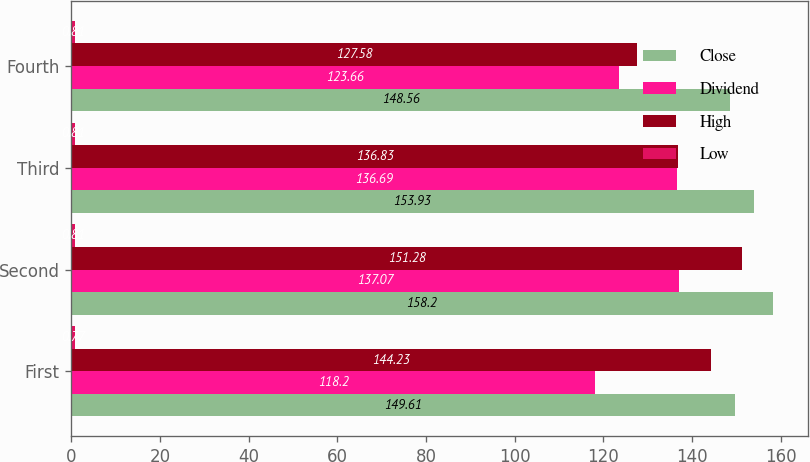Convert chart. <chart><loc_0><loc_0><loc_500><loc_500><stacked_bar_chart><ecel><fcel>First<fcel>Second<fcel>Third<fcel>Fourth<nl><fcel>Close<fcel>149.61<fcel>158.2<fcel>153.93<fcel>148.56<nl><fcel>Dividend<fcel>118.2<fcel>137.07<fcel>136.69<fcel>123.66<nl><fcel>High<fcel>144.23<fcel>151.28<fcel>136.83<fcel>127.58<nl><fcel>Low<fcel>0.77<fcel>0.81<fcel>0.81<fcel>0.81<nl></chart> 